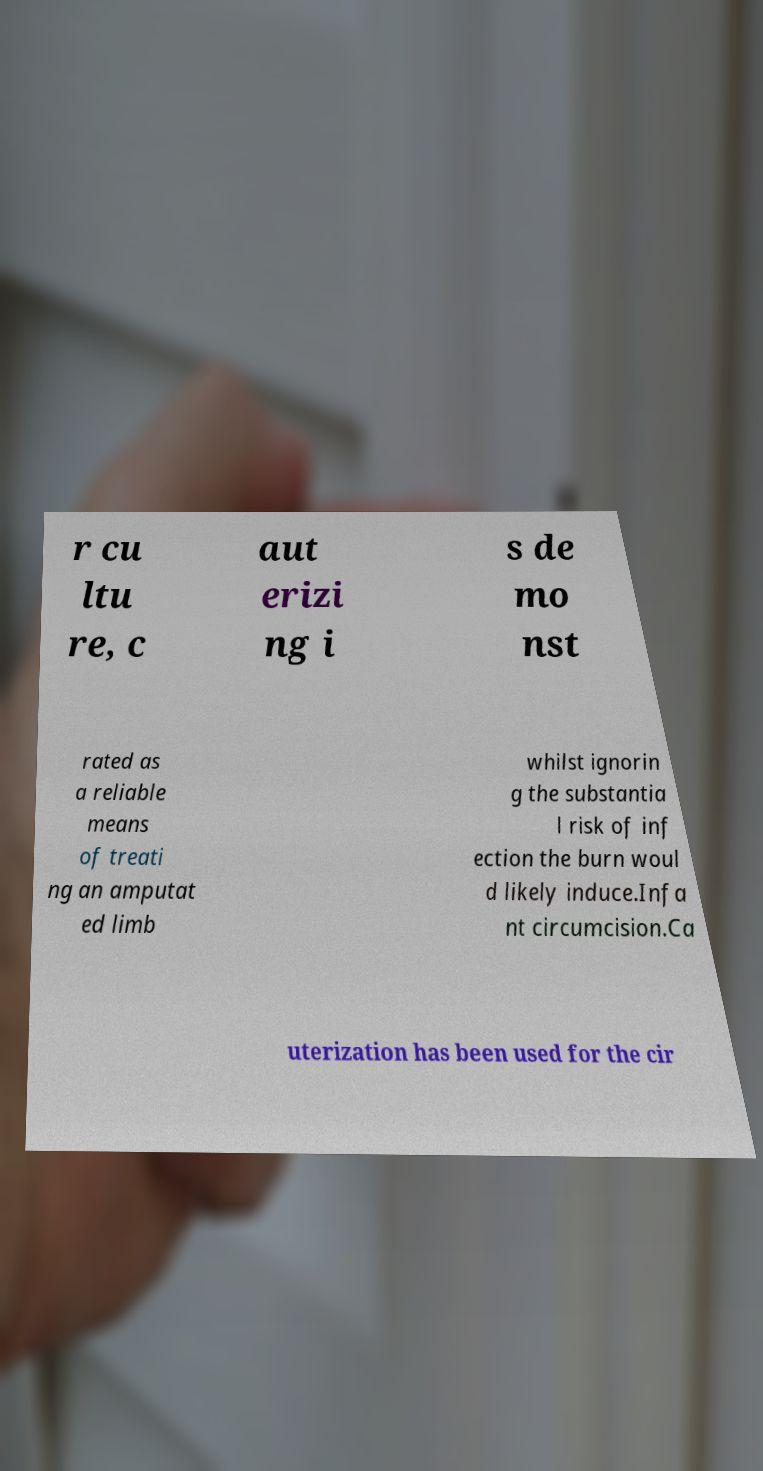For documentation purposes, I need the text within this image transcribed. Could you provide that? r cu ltu re, c aut erizi ng i s de mo nst rated as a reliable means of treati ng an amputat ed limb whilst ignorin g the substantia l risk of inf ection the burn woul d likely induce.Infa nt circumcision.Ca uterization has been used for the cir 